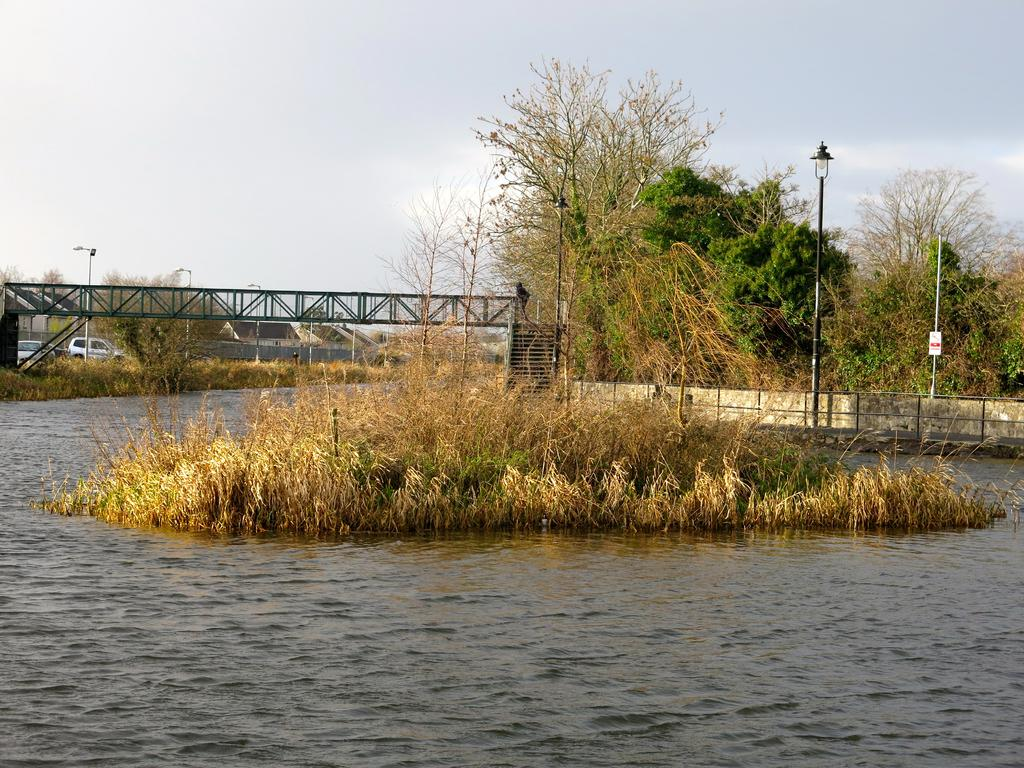Where was the image taken? The image was taken outdoors. What can be seen in the center of the image? There is grass in the center of the image. What is located at the bottom of the image? There is a river at the bottom of the image. What can be seen in the background of the image? There are trees, poles, a bridge, cars, and the sky visible in the background of the image. What type of range is visible in the image? There is no range present in the image. What selection of crops can be seen in the field in the image? There is no field or crops present in the image. 